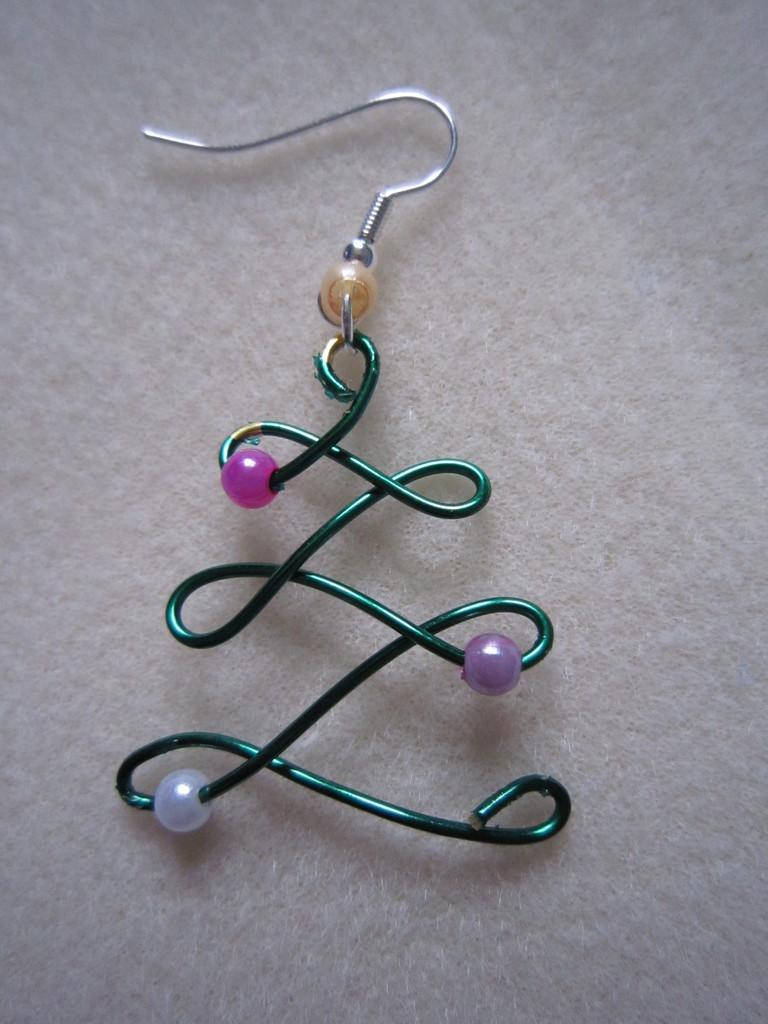What type of accessory is visible in the image? There is an earring in the image. What color is the surface on which the earring is placed? The earring is on a white color surface. How many bottles are visible in the image? There are no bottles present in the image. What time of day is depicted in the image? The provided facts do not give any information about the time of day, so it cannot be determined from the image. 